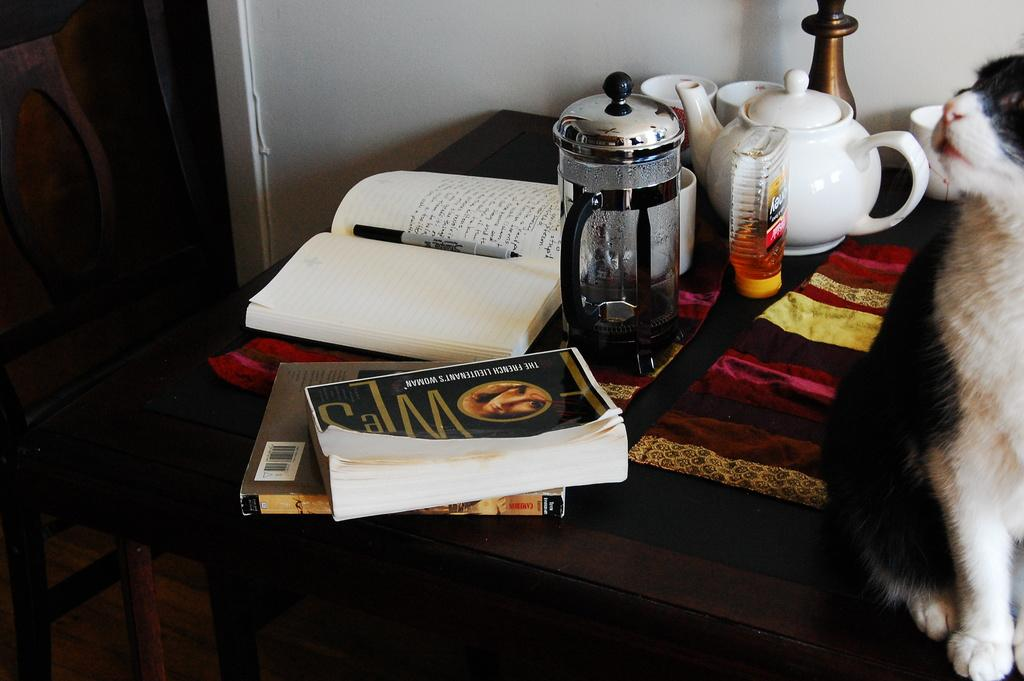What type of furniture is present in the image? There is a table in the image. What items can be seen on the table? There are books, a jar, a kettle, cups, and a cloth on the table. Is there any living creature present in the image? Yes, there is a cat sitting on the table. What sign can be seen on the bedroom wall in the image? There is no bedroom present in the image, and therefore no sign on the wall. What is the value of the cat in the image? The value of the cat cannot be determined from the image, as it is not a quantifiable characteristic. 